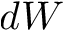Convert formula to latex. <formula><loc_0><loc_0><loc_500><loc_500>d W</formula> 